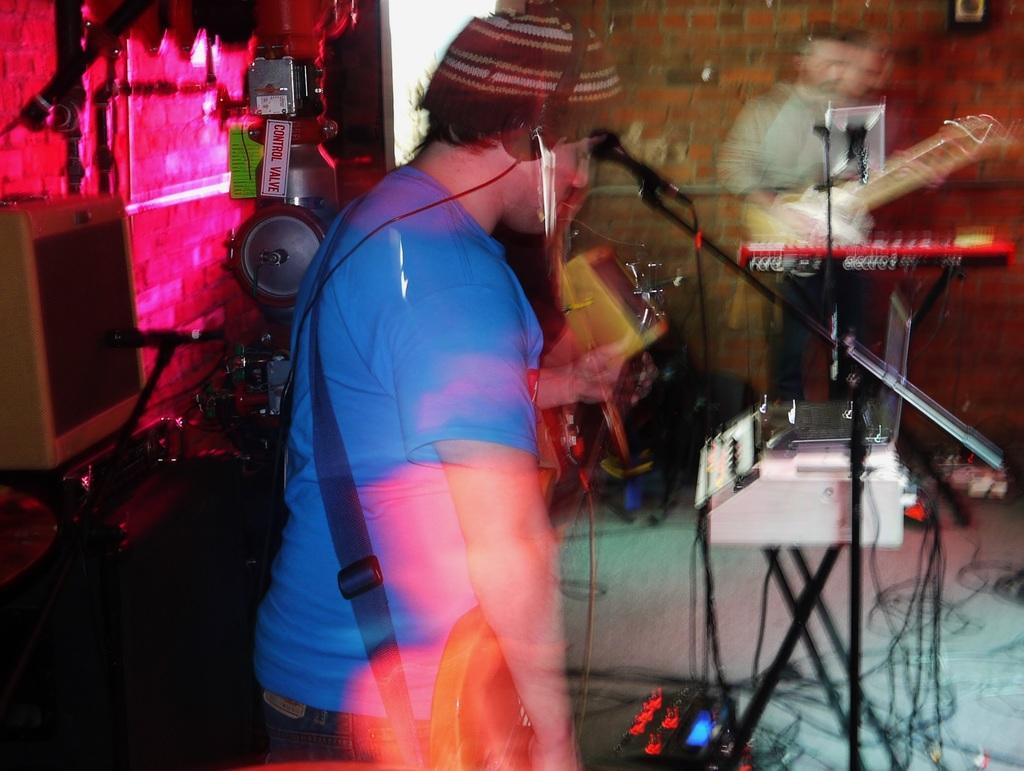Describe this image in one or two sentences. In this image I can see a man is standing and holding a guitar, I can also see he is wearing a cap and a headphone. Here I can see a mic and another person with guitar. 